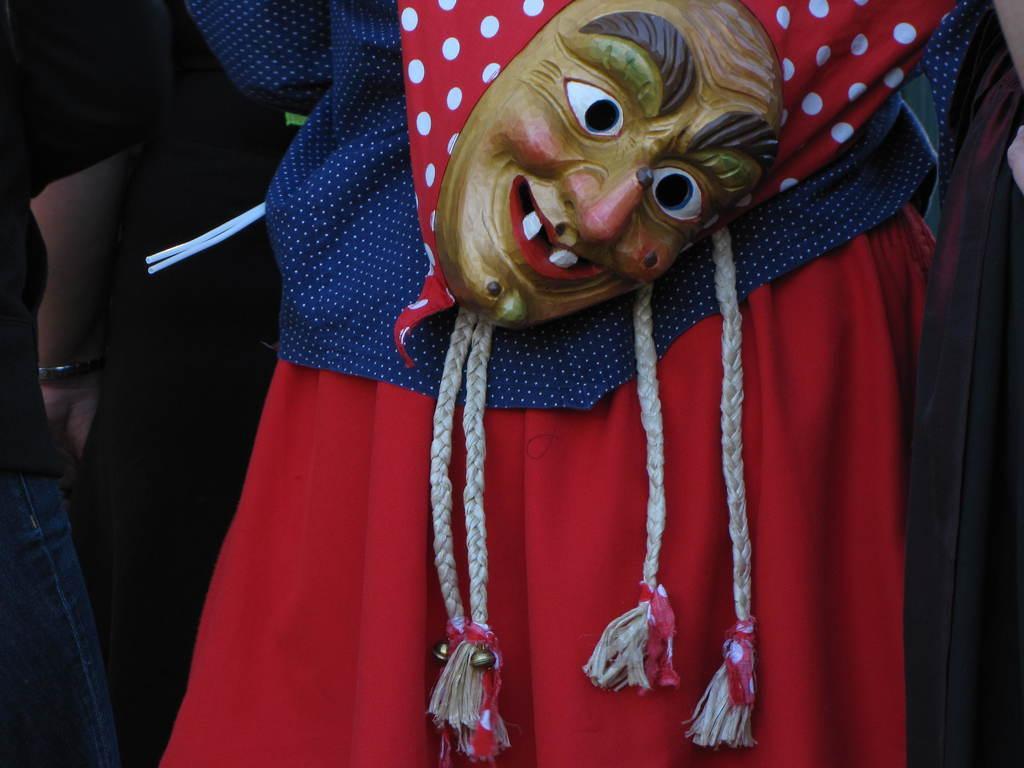Can you describe this image briefly? In this image we can see some people standing. In that a person is wearing the costume and a mask. 